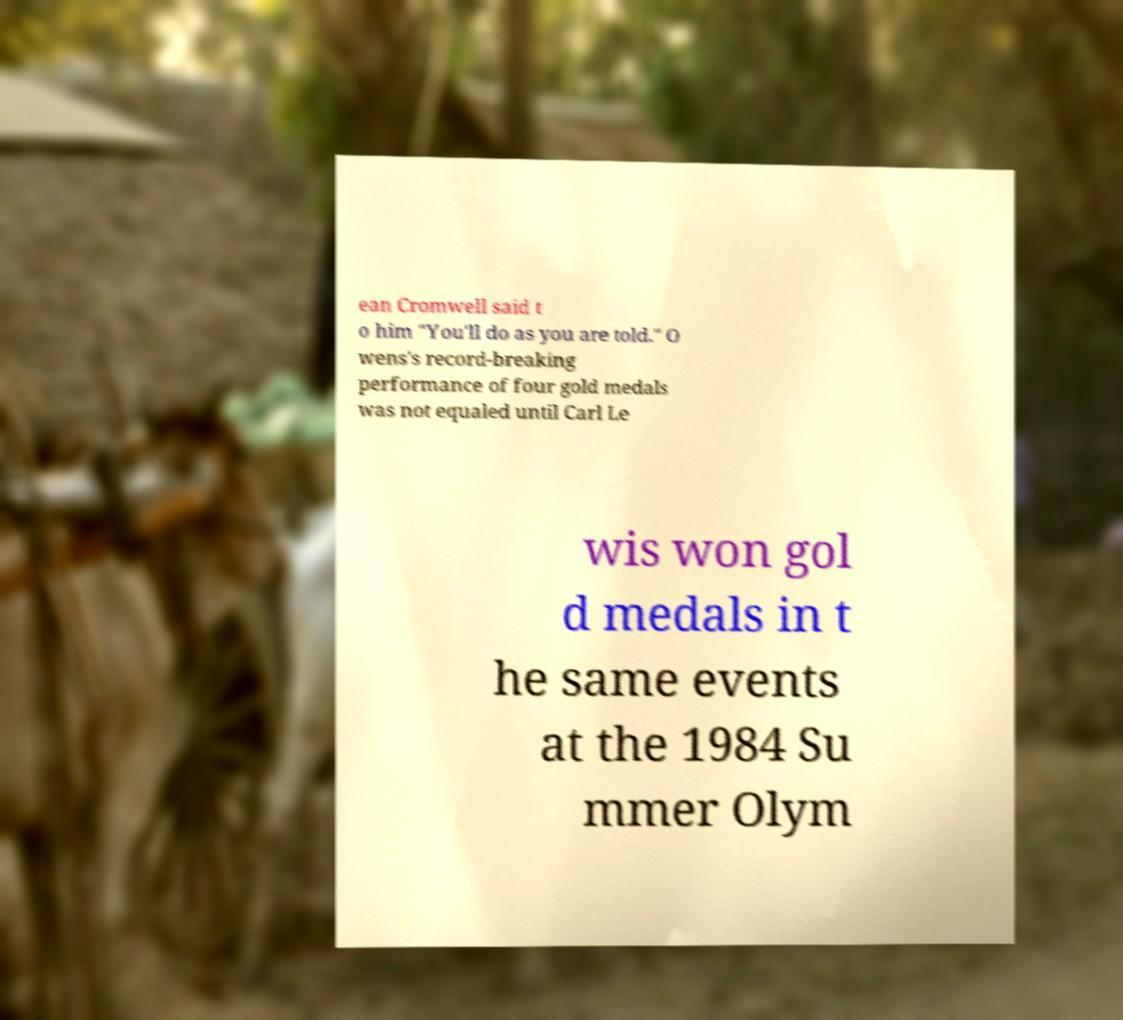For documentation purposes, I need the text within this image transcribed. Could you provide that? ean Cromwell said t o him "You'll do as you are told." O wens's record-breaking performance of four gold medals was not equaled until Carl Le wis won gol d medals in t he same events at the 1984 Su mmer Olym 